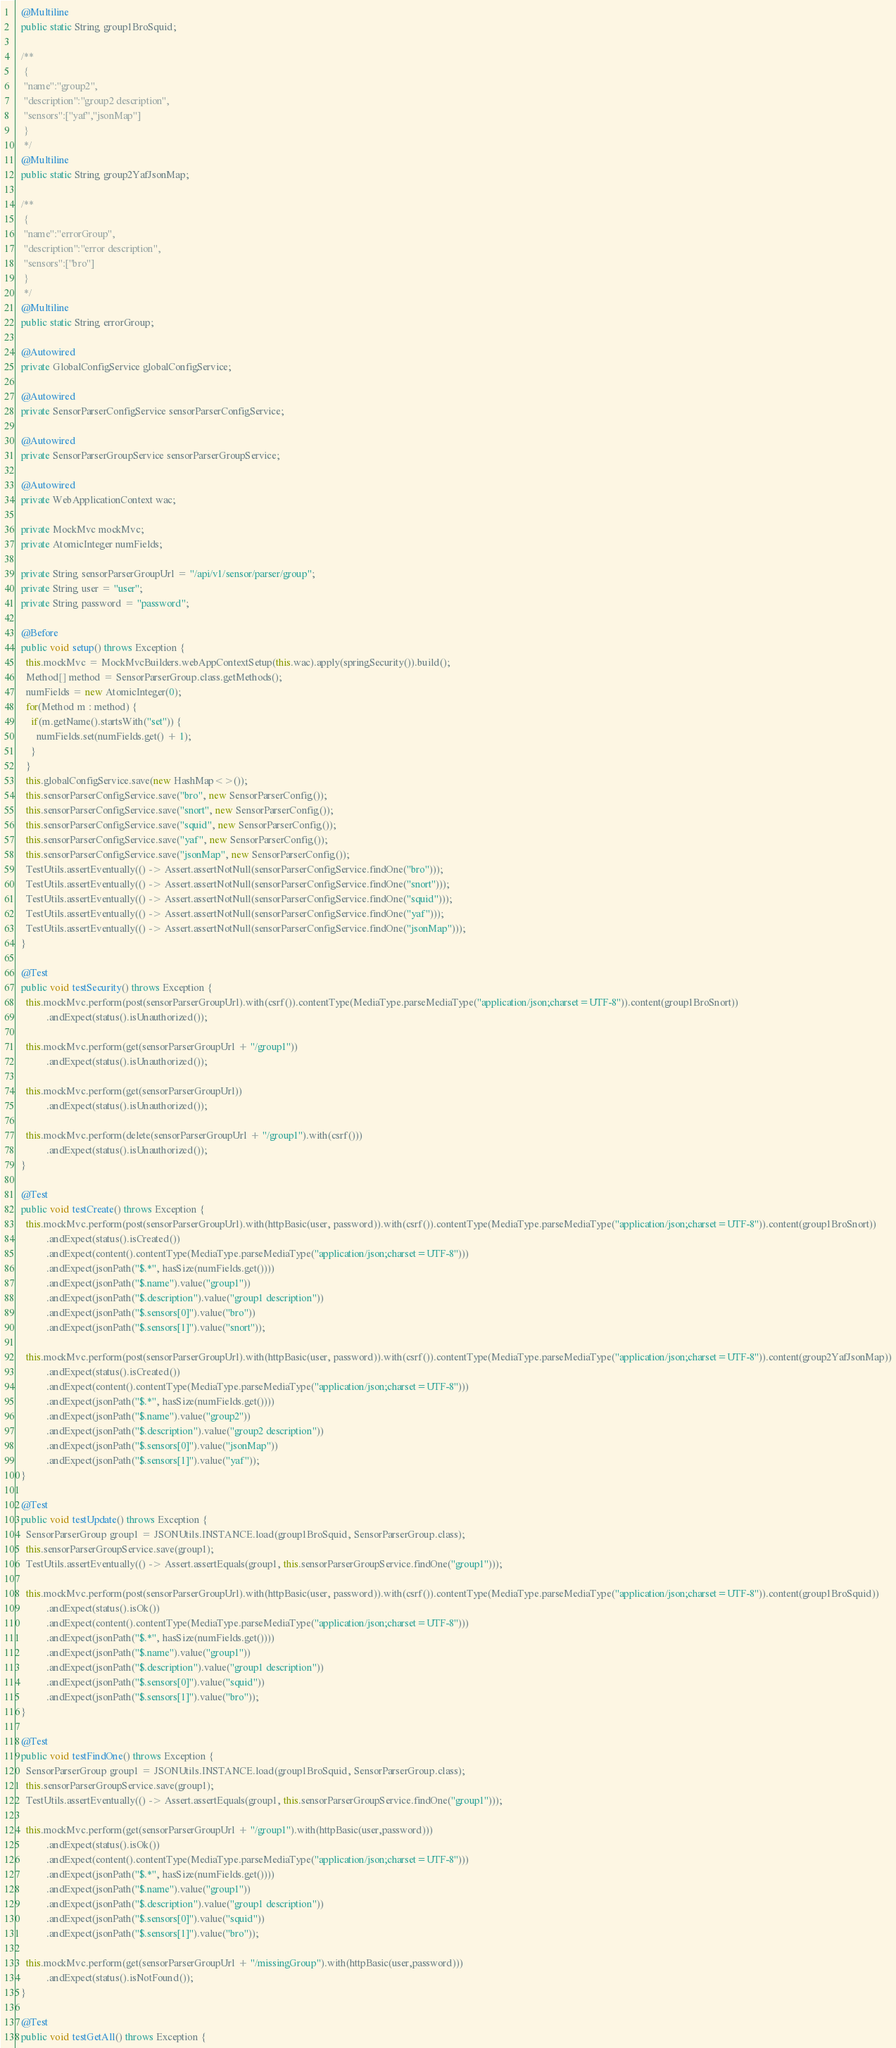Convert code to text. <code><loc_0><loc_0><loc_500><loc_500><_Java_>  @Multiline
  public static String group1BroSquid;

  /**
   {
   "name":"group2",
   "description":"group2 description",
   "sensors":["yaf","jsonMap"]
   }
   */
  @Multiline
  public static String group2YafJsonMap;

  /**
   {
   "name":"errorGroup",
   "description":"error description",
   "sensors":["bro"]
   }
   */
  @Multiline
  public static String errorGroup;

  @Autowired
  private GlobalConfigService globalConfigService;

  @Autowired
  private SensorParserConfigService sensorParserConfigService;

  @Autowired
  private SensorParserGroupService sensorParserGroupService;

  @Autowired
  private WebApplicationContext wac;

  private MockMvc mockMvc;
  private AtomicInteger numFields;

  private String sensorParserGroupUrl = "/api/v1/sensor/parser/group";
  private String user = "user";
  private String password = "password";

  @Before
  public void setup() throws Exception {
    this.mockMvc = MockMvcBuilders.webAppContextSetup(this.wac).apply(springSecurity()).build();
    Method[] method = SensorParserGroup.class.getMethods();
    numFields = new AtomicInteger(0);
    for(Method m : method) {
      if(m.getName().startsWith("set")) {
        numFields.set(numFields.get() + 1);
      }
    }
    this.globalConfigService.save(new HashMap<>());
    this.sensorParserConfigService.save("bro", new SensorParserConfig());
    this.sensorParserConfigService.save("snort", new SensorParserConfig());
    this.sensorParserConfigService.save("squid", new SensorParserConfig());
    this.sensorParserConfigService.save("yaf", new SensorParserConfig());
    this.sensorParserConfigService.save("jsonMap", new SensorParserConfig());
    TestUtils.assertEventually(() -> Assert.assertNotNull(sensorParserConfigService.findOne("bro")));
    TestUtils.assertEventually(() -> Assert.assertNotNull(sensorParserConfigService.findOne("snort")));
    TestUtils.assertEventually(() -> Assert.assertNotNull(sensorParserConfigService.findOne("squid")));
    TestUtils.assertEventually(() -> Assert.assertNotNull(sensorParserConfigService.findOne("yaf")));
    TestUtils.assertEventually(() -> Assert.assertNotNull(sensorParserConfigService.findOne("jsonMap")));
  }

  @Test
  public void testSecurity() throws Exception {
    this.mockMvc.perform(post(sensorParserGroupUrl).with(csrf()).contentType(MediaType.parseMediaType("application/json;charset=UTF-8")).content(group1BroSnort))
            .andExpect(status().isUnauthorized());

    this.mockMvc.perform(get(sensorParserGroupUrl + "/group1"))
            .andExpect(status().isUnauthorized());

    this.mockMvc.perform(get(sensorParserGroupUrl))
            .andExpect(status().isUnauthorized());

    this.mockMvc.perform(delete(sensorParserGroupUrl + "/group1").with(csrf()))
            .andExpect(status().isUnauthorized());
  }

  @Test
  public void testCreate() throws Exception {
    this.mockMvc.perform(post(sensorParserGroupUrl).with(httpBasic(user, password)).with(csrf()).contentType(MediaType.parseMediaType("application/json;charset=UTF-8")).content(group1BroSnort))
            .andExpect(status().isCreated())
            .andExpect(content().contentType(MediaType.parseMediaType("application/json;charset=UTF-8")))
            .andExpect(jsonPath("$.*", hasSize(numFields.get())))
            .andExpect(jsonPath("$.name").value("group1"))
            .andExpect(jsonPath("$.description").value("group1 description"))
            .andExpect(jsonPath("$.sensors[0]").value("bro"))
            .andExpect(jsonPath("$.sensors[1]").value("snort"));

    this.mockMvc.perform(post(sensorParserGroupUrl).with(httpBasic(user, password)).with(csrf()).contentType(MediaType.parseMediaType("application/json;charset=UTF-8")).content(group2YafJsonMap))
            .andExpect(status().isCreated())
            .andExpect(content().contentType(MediaType.parseMediaType("application/json;charset=UTF-8")))
            .andExpect(jsonPath("$.*", hasSize(numFields.get())))
            .andExpect(jsonPath("$.name").value("group2"))
            .andExpect(jsonPath("$.description").value("group2 description"))
            .andExpect(jsonPath("$.sensors[0]").value("jsonMap"))
            .andExpect(jsonPath("$.sensors[1]").value("yaf"));
  }

  @Test
  public void testUpdate() throws Exception {
    SensorParserGroup group1 = JSONUtils.INSTANCE.load(group1BroSquid, SensorParserGroup.class);
    this.sensorParserGroupService.save(group1);
    TestUtils.assertEventually(() -> Assert.assertEquals(group1, this.sensorParserGroupService.findOne("group1")));

    this.mockMvc.perform(post(sensorParserGroupUrl).with(httpBasic(user, password)).with(csrf()).contentType(MediaType.parseMediaType("application/json;charset=UTF-8")).content(group1BroSquid))
            .andExpect(status().isOk())
            .andExpect(content().contentType(MediaType.parseMediaType("application/json;charset=UTF-8")))
            .andExpect(jsonPath("$.*", hasSize(numFields.get())))
            .andExpect(jsonPath("$.name").value("group1"))
            .andExpect(jsonPath("$.description").value("group1 description"))
            .andExpect(jsonPath("$.sensors[0]").value("squid"))
            .andExpect(jsonPath("$.sensors[1]").value("bro"));
  }

  @Test
  public void testFindOne() throws Exception {
    SensorParserGroup group1 = JSONUtils.INSTANCE.load(group1BroSquid, SensorParserGroup.class);
    this.sensorParserGroupService.save(group1);
    TestUtils.assertEventually(() -> Assert.assertEquals(group1, this.sensorParserGroupService.findOne("group1")));

    this.mockMvc.perform(get(sensorParserGroupUrl + "/group1").with(httpBasic(user,password)))
            .andExpect(status().isOk())
            .andExpect(content().contentType(MediaType.parseMediaType("application/json;charset=UTF-8")))
            .andExpect(jsonPath("$.*", hasSize(numFields.get())))
            .andExpect(jsonPath("$.name").value("group1"))
            .andExpect(jsonPath("$.description").value("group1 description"))
            .andExpect(jsonPath("$.sensors[0]").value("squid"))
            .andExpect(jsonPath("$.sensors[1]").value("bro"));

    this.mockMvc.perform(get(sensorParserGroupUrl + "/missingGroup").with(httpBasic(user,password)))
            .andExpect(status().isNotFound());
  }

  @Test
  public void testGetAll() throws Exception {</code> 